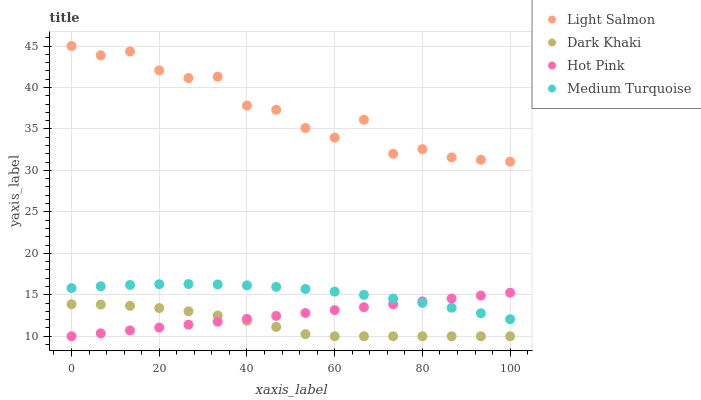Does Dark Khaki have the minimum area under the curve?
Answer yes or no. Yes. Does Light Salmon have the maximum area under the curve?
Answer yes or no. Yes. Does Hot Pink have the minimum area under the curve?
Answer yes or no. No. Does Hot Pink have the maximum area under the curve?
Answer yes or no. No. Is Hot Pink the smoothest?
Answer yes or no. Yes. Is Light Salmon the roughest?
Answer yes or no. Yes. Is Light Salmon the smoothest?
Answer yes or no. No. Is Hot Pink the roughest?
Answer yes or no. No. Does Dark Khaki have the lowest value?
Answer yes or no. Yes. Does Light Salmon have the lowest value?
Answer yes or no. No. Does Light Salmon have the highest value?
Answer yes or no. Yes. Does Hot Pink have the highest value?
Answer yes or no. No. Is Dark Khaki less than Light Salmon?
Answer yes or no. Yes. Is Light Salmon greater than Medium Turquoise?
Answer yes or no. Yes. Does Medium Turquoise intersect Hot Pink?
Answer yes or no. Yes. Is Medium Turquoise less than Hot Pink?
Answer yes or no. No. Is Medium Turquoise greater than Hot Pink?
Answer yes or no. No. Does Dark Khaki intersect Light Salmon?
Answer yes or no. No. 